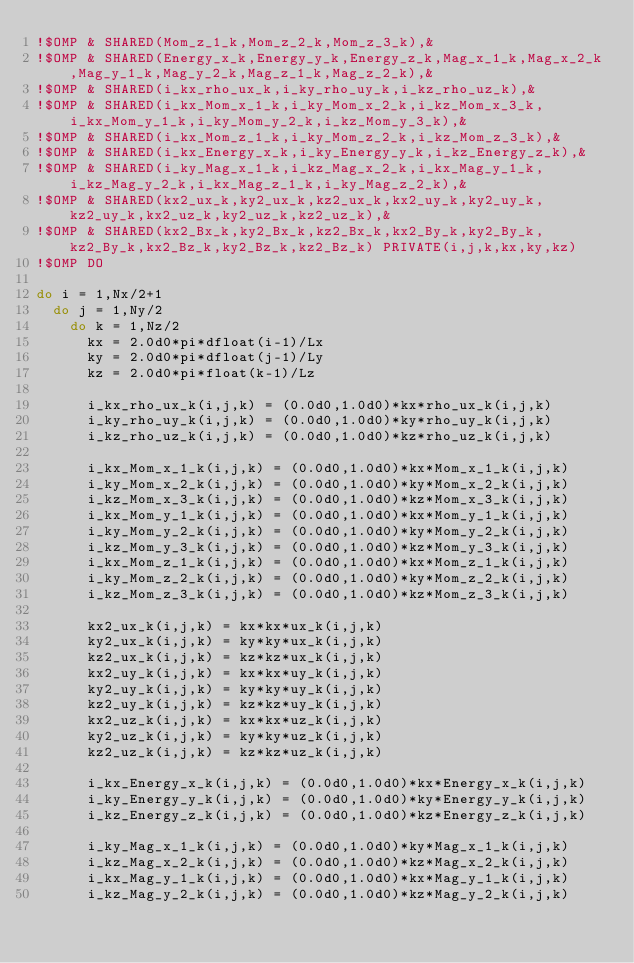<code> <loc_0><loc_0><loc_500><loc_500><_FORTRAN_>!$OMP & SHARED(Mom_z_1_k,Mom_z_2_k,Mom_z_3_k),&
!$OMP & SHARED(Energy_x_k,Energy_y_k,Energy_z_k,Mag_x_1_k,Mag_x_2_k,Mag_y_1_k,Mag_y_2_k,Mag_z_1_k,Mag_z_2_k),&
!$OMP & SHARED(i_kx_rho_ux_k,i_ky_rho_uy_k,i_kz_rho_uz_k),&
!$OMP & SHARED(i_kx_Mom_x_1_k,i_ky_Mom_x_2_k,i_kz_Mom_x_3_k,i_kx_Mom_y_1_k,i_ky_Mom_y_2_k,i_kz_Mom_y_3_k),&
!$OMP & SHARED(i_kx_Mom_z_1_k,i_ky_Mom_z_2_k,i_kz_Mom_z_3_k),&
!$OMP & SHARED(i_kx_Energy_x_k,i_ky_Energy_y_k,i_kz_Energy_z_k),&
!$OMP & SHARED(i_ky_Mag_x_1_k,i_kz_Mag_x_2_k,i_kx_Mag_y_1_k,i_kz_Mag_y_2_k,i_kx_Mag_z_1_k,i_ky_Mag_z_2_k),&
!$OMP & SHARED(kx2_ux_k,ky2_ux_k,kz2_ux_k,kx2_uy_k,ky2_uy_k,kz2_uy_k,kx2_uz_k,ky2_uz_k,kz2_uz_k),&
!$OMP & SHARED(kx2_Bx_k,ky2_Bx_k,kz2_Bx_k,kx2_By_k,ky2_By_k,kz2_By_k,kx2_Bz_k,ky2_Bz_k,kz2_Bz_k) PRIVATE(i,j,k,kx,ky,kz)
!$OMP DO

do i = 1,Nx/2+1
  do j = 1,Ny/2
    do k = 1,Nz/2
      kx = 2.0d0*pi*dfloat(i-1)/Lx
      ky = 2.0d0*pi*dfloat(j-1)/Ly
      kz = 2.0d0*pi*float(k-1)/Lz

      i_kx_rho_ux_k(i,j,k) = (0.0d0,1.0d0)*kx*rho_ux_k(i,j,k)
      i_ky_rho_uy_k(i,j,k) = (0.0d0,1.0d0)*ky*rho_uy_k(i,j,k)
      i_kz_rho_uz_k(i,j,k) = (0.0d0,1.0d0)*kz*rho_uz_k(i,j,k)

      i_kx_Mom_x_1_k(i,j,k) = (0.0d0,1.0d0)*kx*Mom_x_1_k(i,j,k)
      i_ky_Mom_x_2_k(i,j,k) = (0.0d0,1.0d0)*ky*Mom_x_2_k(i,j,k)
      i_kz_Mom_x_3_k(i,j,k) = (0.0d0,1.0d0)*kz*Mom_x_3_k(i,j,k)
      i_kx_Mom_y_1_k(i,j,k) = (0.0d0,1.0d0)*kx*Mom_y_1_k(i,j,k)
      i_ky_Mom_y_2_k(i,j,k) = (0.0d0,1.0d0)*ky*Mom_y_2_k(i,j,k)
      i_kz_Mom_y_3_k(i,j,k) = (0.0d0,1.0d0)*kz*Mom_y_3_k(i,j,k)
      i_kx_Mom_z_1_k(i,j,k) = (0.0d0,1.0d0)*kx*Mom_z_1_k(i,j,k)
      i_ky_Mom_z_2_k(i,j,k) = (0.0d0,1.0d0)*ky*Mom_z_2_k(i,j,k)
      i_kz_Mom_z_3_k(i,j,k) = (0.0d0,1.0d0)*kz*Mom_z_3_k(i,j,k)

      kx2_ux_k(i,j,k) = kx*kx*ux_k(i,j,k)
      ky2_ux_k(i,j,k) = ky*ky*ux_k(i,j,k)
      kz2_ux_k(i,j,k) = kz*kz*ux_k(i,j,k)
      kx2_uy_k(i,j,k) = kx*kx*uy_k(i,j,k)
      ky2_uy_k(i,j,k) = ky*ky*uy_k(i,j,k)
      kz2_uy_k(i,j,k) = kz*kz*uy_k(i,j,k)
      kx2_uz_k(i,j,k) = kx*kx*uz_k(i,j,k)
      ky2_uz_k(i,j,k) = ky*ky*uz_k(i,j,k)
      kz2_uz_k(i,j,k) = kz*kz*uz_k(i,j,k)

      i_kx_Energy_x_k(i,j,k) = (0.0d0,1.0d0)*kx*Energy_x_k(i,j,k)
      i_ky_Energy_y_k(i,j,k) = (0.0d0,1.0d0)*ky*Energy_y_k(i,j,k)
      i_kz_Energy_z_k(i,j,k) = (0.0d0,1.0d0)*kz*Energy_z_k(i,j,k)

      i_ky_Mag_x_1_k(i,j,k) = (0.0d0,1.0d0)*ky*Mag_x_1_k(i,j,k)
      i_kz_Mag_x_2_k(i,j,k) = (0.0d0,1.0d0)*kz*Mag_x_2_k(i,j,k)
      i_kx_Mag_y_1_k(i,j,k) = (0.0d0,1.0d0)*kx*Mag_y_1_k(i,j,k)
      i_kz_Mag_y_2_k(i,j,k) = (0.0d0,1.0d0)*kz*Mag_y_2_k(i,j,k)</code> 